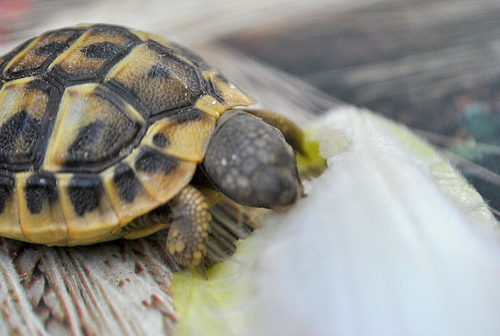<image>
Can you confirm if the turtle is to the right of the wood? No. The turtle is not to the right of the wood. The horizontal positioning shows a different relationship. 